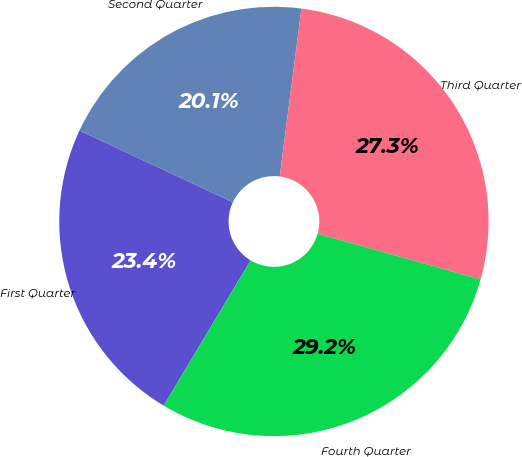Convert chart. <chart><loc_0><loc_0><loc_500><loc_500><pie_chart><fcel>First Quarter<fcel>Second Quarter<fcel>Third Quarter<fcel>Fourth Quarter<nl><fcel>23.38%<fcel>20.08%<fcel>27.31%<fcel>29.23%<nl></chart> 